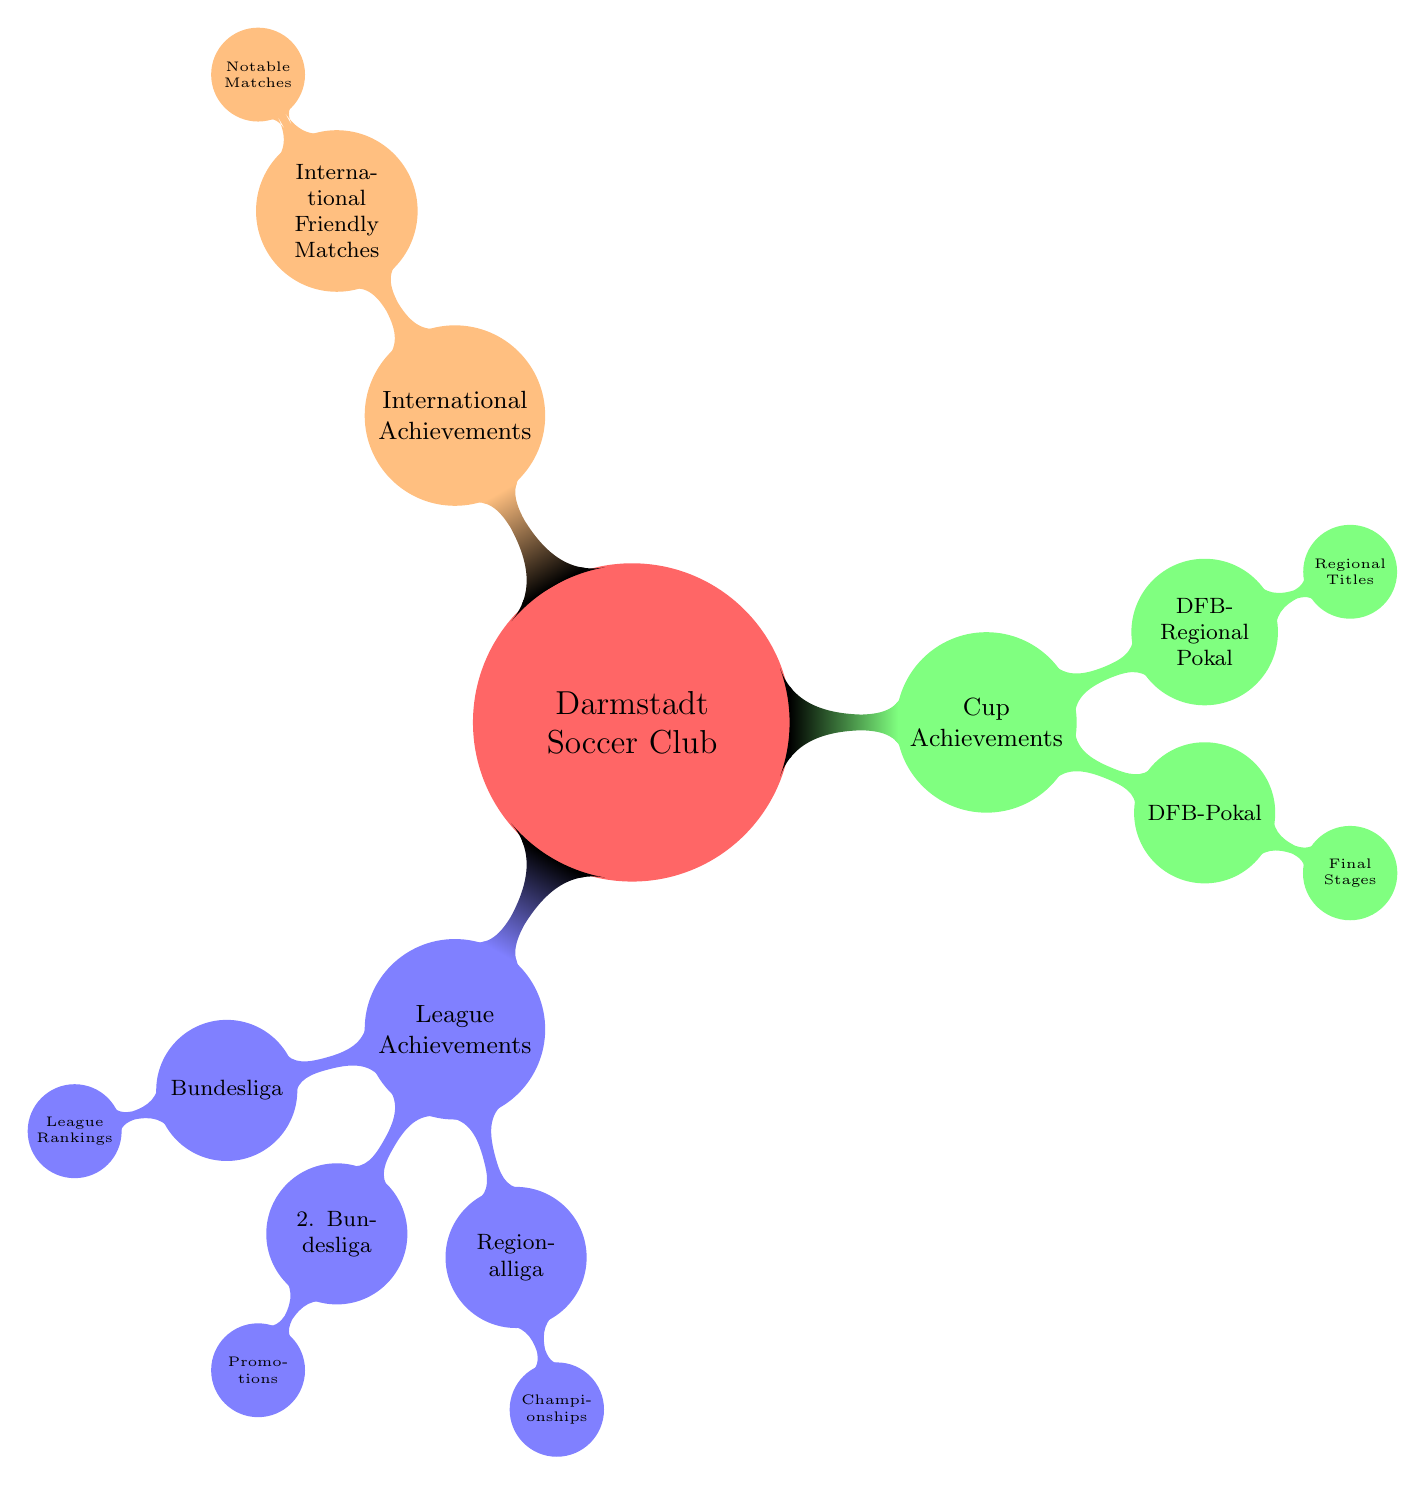What are the main categories of achievements listed in the diagram? The diagram has three main categories: League Achievements, Cup Achievements, and International Achievements. These are the highest-level nodes that represent the overarching areas of accomplishment for the Darmstadt Soccer Club.
Answer: League Achievements, Cup Achievements, International Achievements Which league has achievements related to championships? The node for the Regionalliga under League Achievements specifically mentions Championships as its type of achievement, indicating that this league is associated with that category of success.
Answer: Regionalliga How many types of League Achievements are there? In the diagram, the League Achievements category contains three types: Bundesliga, 2. Bundesliga, and Regionalliga. By counting these nodes, we find a total of three types under this category.
Answer: 3 What is a specific type of Cup Achievement mentioned in the diagram? The diagram specifies the DFB-Pokal as a type of Cup Achievement. This is part of the Cup Achievements category and is highlighted in the second-level node.
Answer: DFB-Pokal What is the relationship between International Achievements and Notable Matches? The diagram indicates that International Achievements is a broader category that includes International Friendly Matches, which in turn contains Notable Matches as a specific aspect. This shows a hierarchical relationship where Notable Matches are a detail within Friendly Matches under International Achievements.
Answer: Notable Matches is a detail within International Achievements How many child nodes does the DFB-Pokal node have? The DFB-Pokal node contains only one child node, which is called Final Stages, meaning it represents a single area of focus regarding achievements in that cup.
Answer: 1 